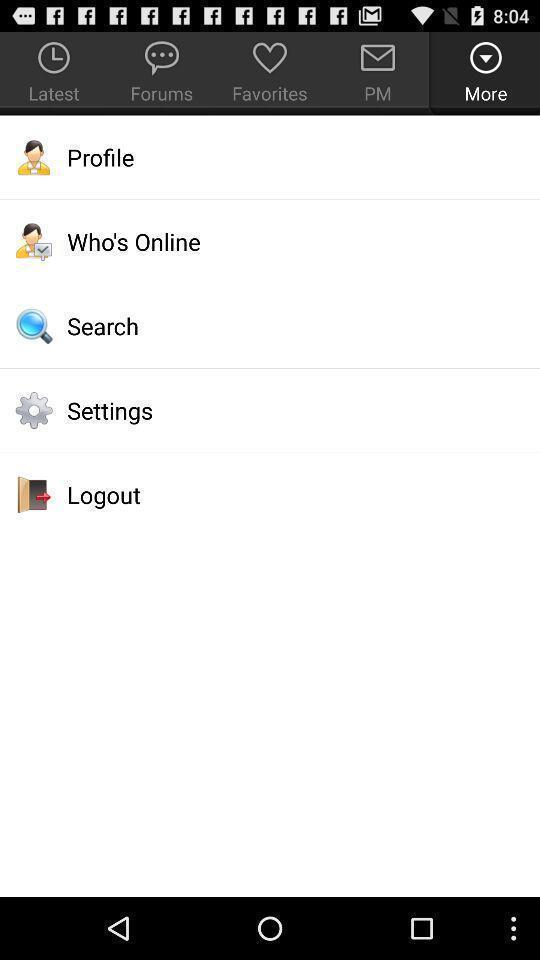Summarize the information in this screenshot. Various options displayed. 